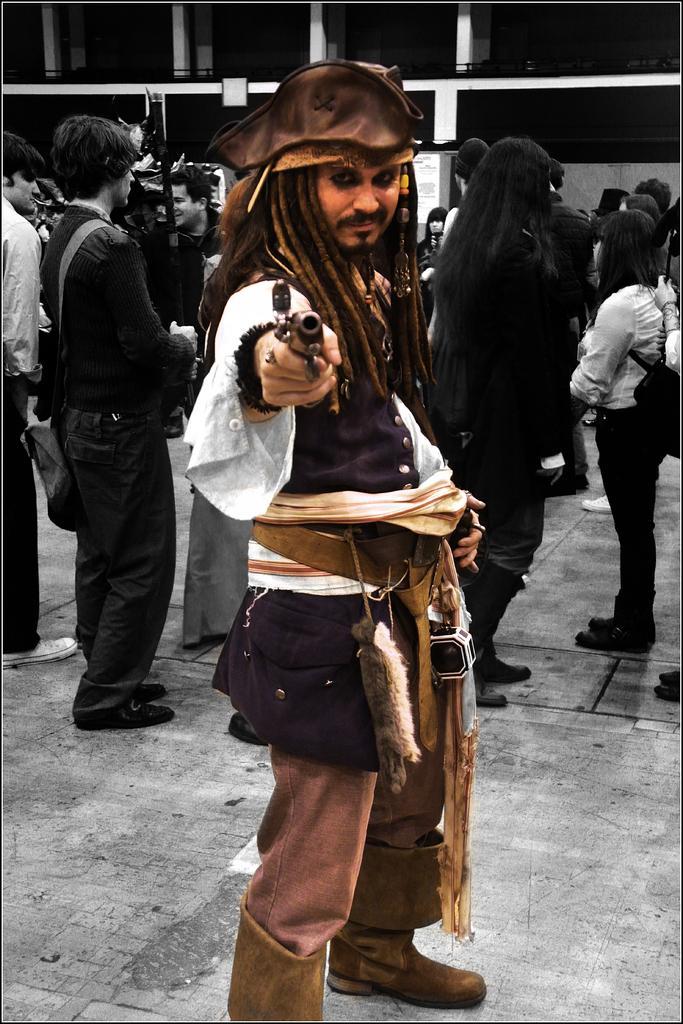Describe this image in one or two sentences. In the foreground of the picture I can see a man standing on the floor and he is in the filmy costume. There is a cap on his head and he is holding a pistol in his right hand. In the background, I can see a few persons standing on the floor. I can see the building at the top of the picture. 